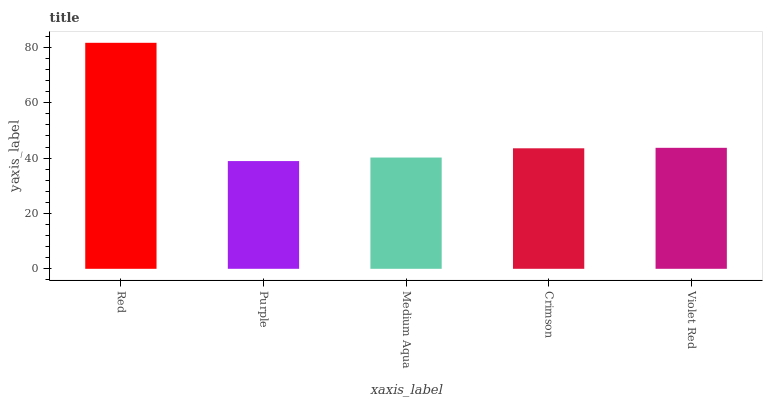Is Purple the minimum?
Answer yes or no. Yes. Is Red the maximum?
Answer yes or no. Yes. Is Medium Aqua the minimum?
Answer yes or no. No. Is Medium Aqua the maximum?
Answer yes or no. No. Is Medium Aqua greater than Purple?
Answer yes or no. Yes. Is Purple less than Medium Aqua?
Answer yes or no. Yes. Is Purple greater than Medium Aqua?
Answer yes or no. No. Is Medium Aqua less than Purple?
Answer yes or no. No. Is Crimson the high median?
Answer yes or no. Yes. Is Crimson the low median?
Answer yes or no. Yes. Is Medium Aqua the high median?
Answer yes or no. No. Is Medium Aqua the low median?
Answer yes or no. No. 